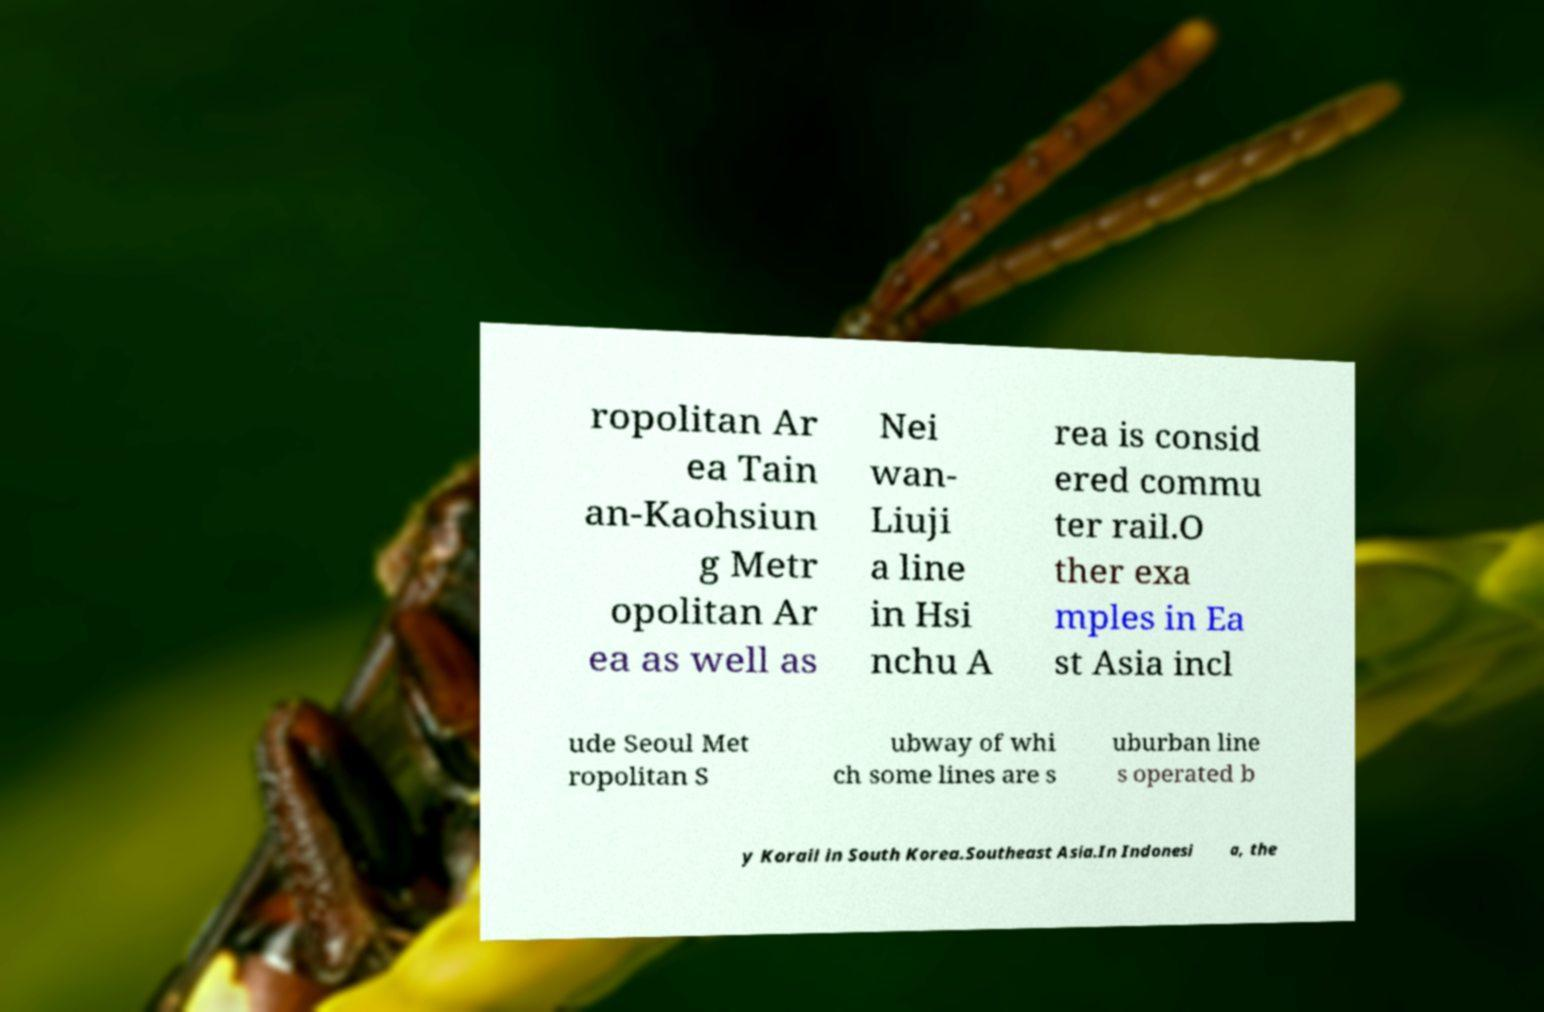Could you extract and type out the text from this image? ropolitan Ar ea Tain an-Kaohsiun g Metr opolitan Ar ea as well as Nei wan- Liuji a line in Hsi nchu A rea is consid ered commu ter rail.O ther exa mples in Ea st Asia incl ude Seoul Met ropolitan S ubway of whi ch some lines are s uburban line s operated b y Korail in South Korea.Southeast Asia.In Indonesi a, the 